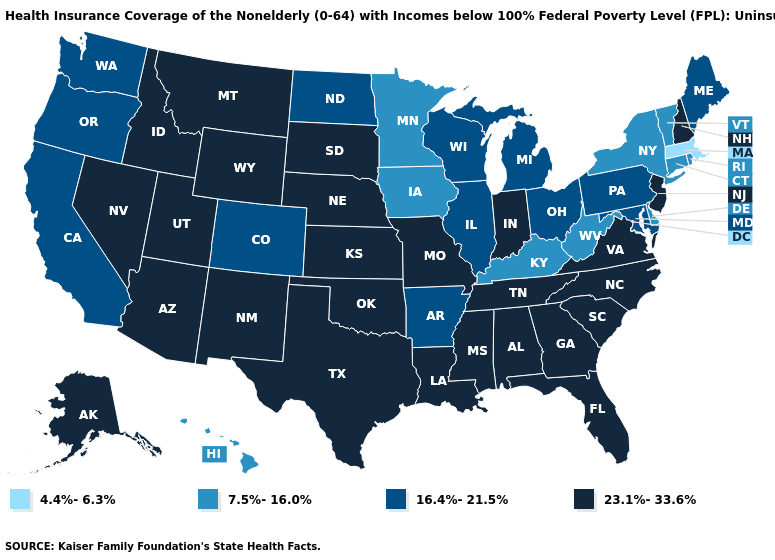Does Colorado have the same value as Washington?
Give a very brief answer. Yes. Which states have the lowest value in the USA?
Concise answer only. Massachusetts. Which states have the lowest value in the MidWest?
Quick response, please. Iowa, Minnesota. What is the value of Kentucky?
Be succinct. 7.5%-16.0%. Which states have the lowest value in the West?
Be succinct. Hawaii. Name the states that have a value in the range 23.1%-33.6%?
Short answer required. Alabama, Alaska, Arizona, Florida, Georgia, Idaho, Indiana, Kansas, Louisiana, Mississippi, Missouri, Montana, Nebraska, Nevada, New Hampshire, New Jersey, New Mexico, North Carolina, Oklahoma, South Carolina, South Dakota, Tennessee, Texas, Utah, Virginia, Wyoming. What is the highest value in states that border Connecticut?
Answer briefly. 7.5%-16.0%. What is the value of Wisconsin?
Keep it brief. 16.4%-21.5%. Among the states that border Oregon , which have the lowest value?
Keep it brief. California, Washington. How many symbols are there in the legend?
Quick response, please. 4. Name the states that have a value in the range 4.4%-6.3%?
Write a very short answer. Massachusetts. How many symbols are there in the legend?
Quick response, please. 4. Does Iowa have the highest value in the MidWest?
Write a very short answer. No. Name the states that have a value in the range 16.4%-21.5%?
Keep it brief. Arkansas, California, Colorado, Illinois, Maine, Maryland, Michigan, North Dakota, Ohio, Oregon, Pennsylvania, Washington, Wisconsin. Name the states that have a value in the range 4.4%-6.3%?
Quick response, please. Massachusetts. 